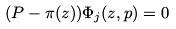<formula> <loc_0><loc_0><loc_500><loc_500>( P - \pi ( z ) ) \Phi _ { j } ( z , p ) = 0</formula> 